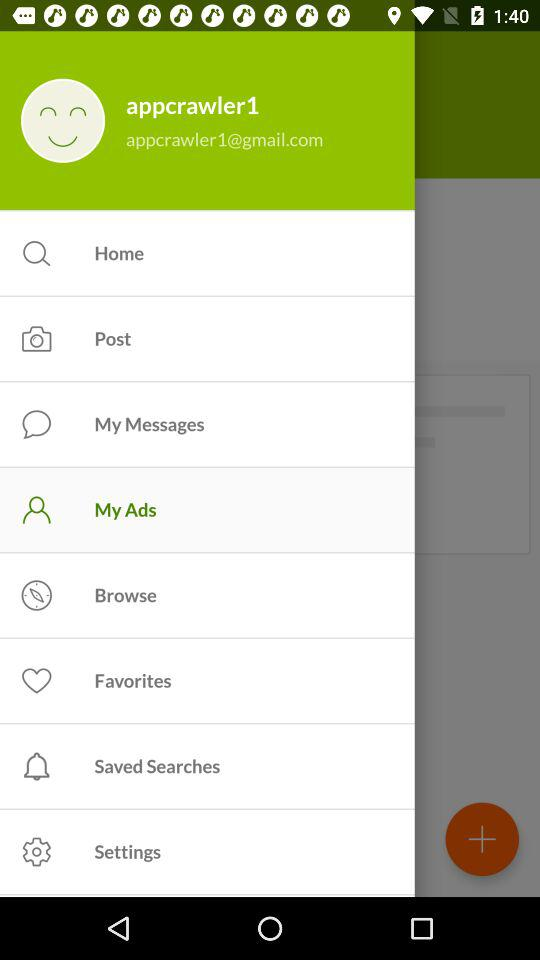How many items are in the menu?
Answer the question using a single word or phrase. 9 